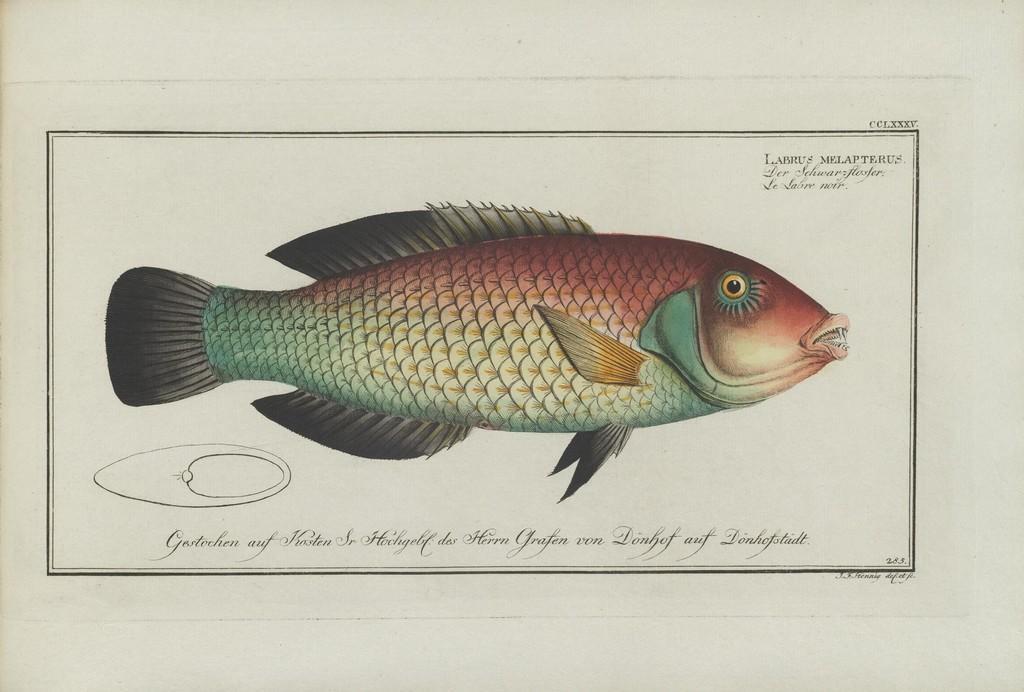Could you give a brief overview of what you see in this image? In this picture I can see a paper on an object, there are words, numbers, there is an image of a fish on the paper. 